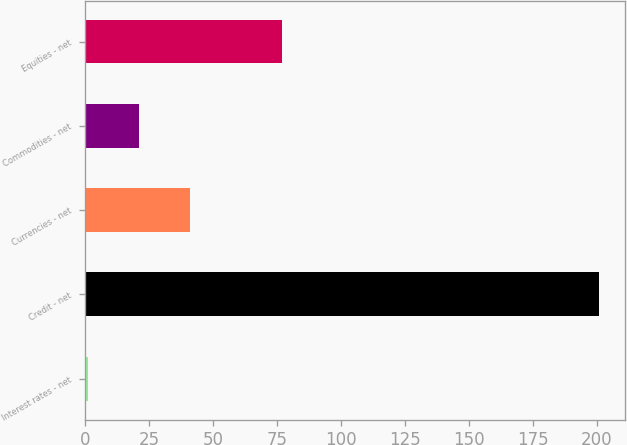<chart> <loc_0><loc_0><loc_500><loc_500><bar_chart><fcel>Interest rates - net<fcel>Credit - net<fcel>Currencies - net<fcel>Commodities - net<fcel>Equities - net<nl><fcel>1<fcel>201<fcel>41<fcel>21<fcel>77<nl></chart> 